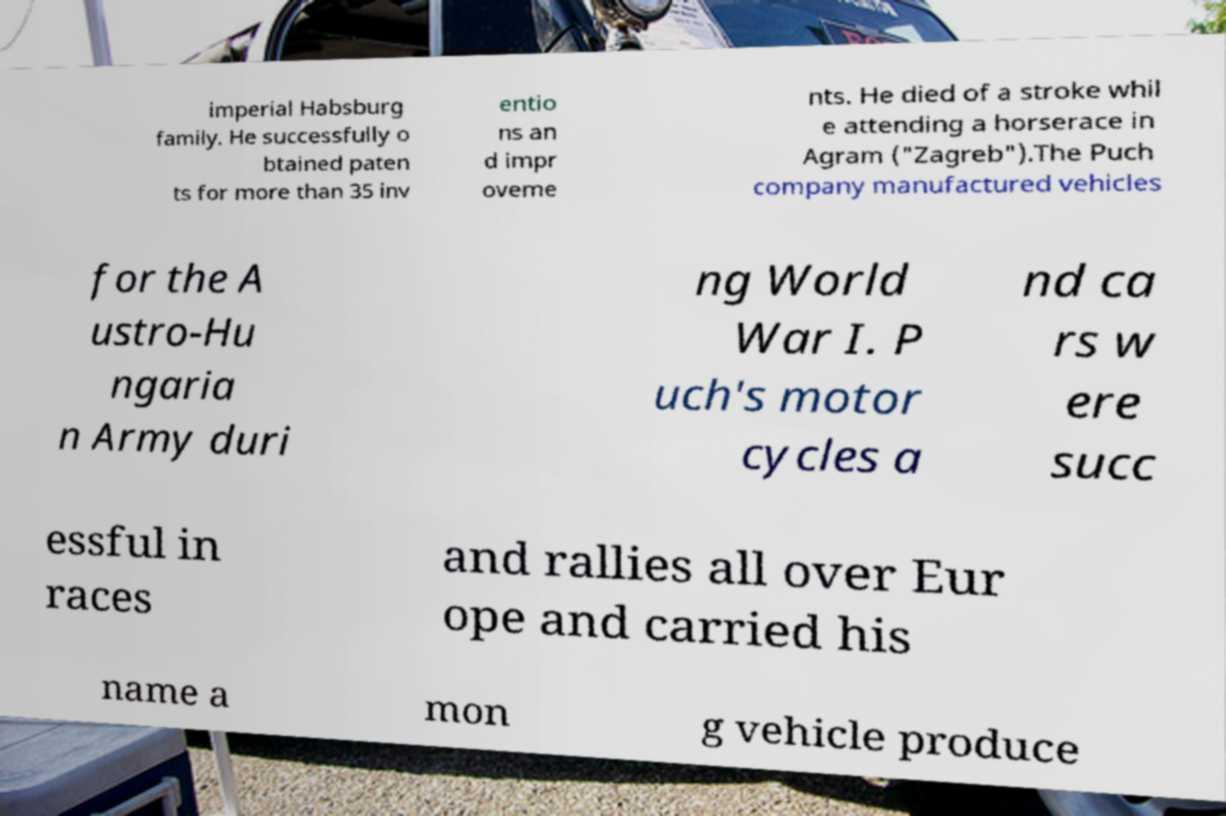For documentation purposes, I need the text within this image transcribed. Could you provide that? imperial Habsburg family. He successfully o btained paten ts for more than 35 inv entio ns an d impr oveme nts. He died of a stroke whil e attending a horserace in Agram ("Zagreb").The Puch company manufactured vehicles for the A ustro-Hu ngaria n Army duri ng World War I. P uch's motor cycles a nd ca rs w ere succ essful in races and rallies all over Eur ope and carried his name a mon g vehicle produce 